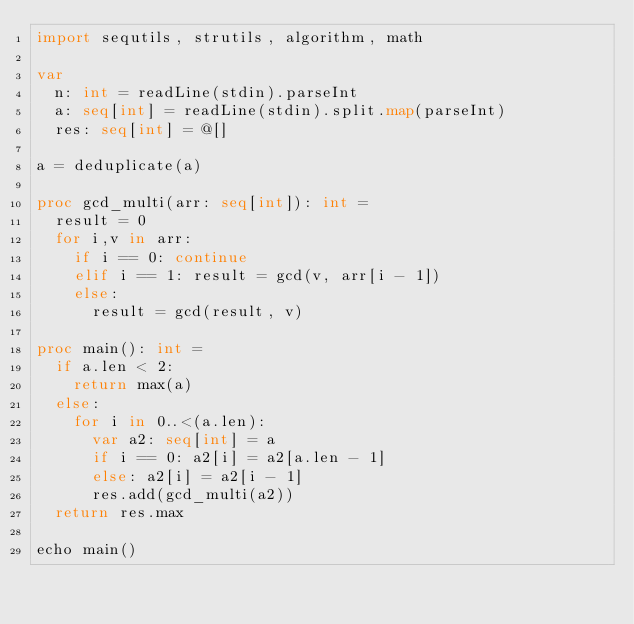Convert code to text. <code><loc_0><loc_0><loc_500><loc_500><_Nim_>import sequtils, strutils, algorithm, math

var
  n: int = readLine(stdin).parseInt
  a: seq[int] = readLine(stdin).split.map(parseInt)
  res: seq[int] = @[]

a = deduplicate(a)

proc gcd_multi(arr: seq[int]): int =
  result = 0
  for i,v in arr:
    if i == 0: continue
    elif i == 1: result = gcd(v, arr[i - 1])
    else:
      result = gcd(result, v)

proc main(): int =
  if a.len < 2:
    return max(a)
  else:
    for i in 0..<(a.len):
      var a2: seq[int] = a
      if i == 0: a2[i] = a2[a.len - 1]
      else: a2[i] = a2[i - 1]
      res.add(gcd_multi(a2))
  return res.max

echo main()</code> 